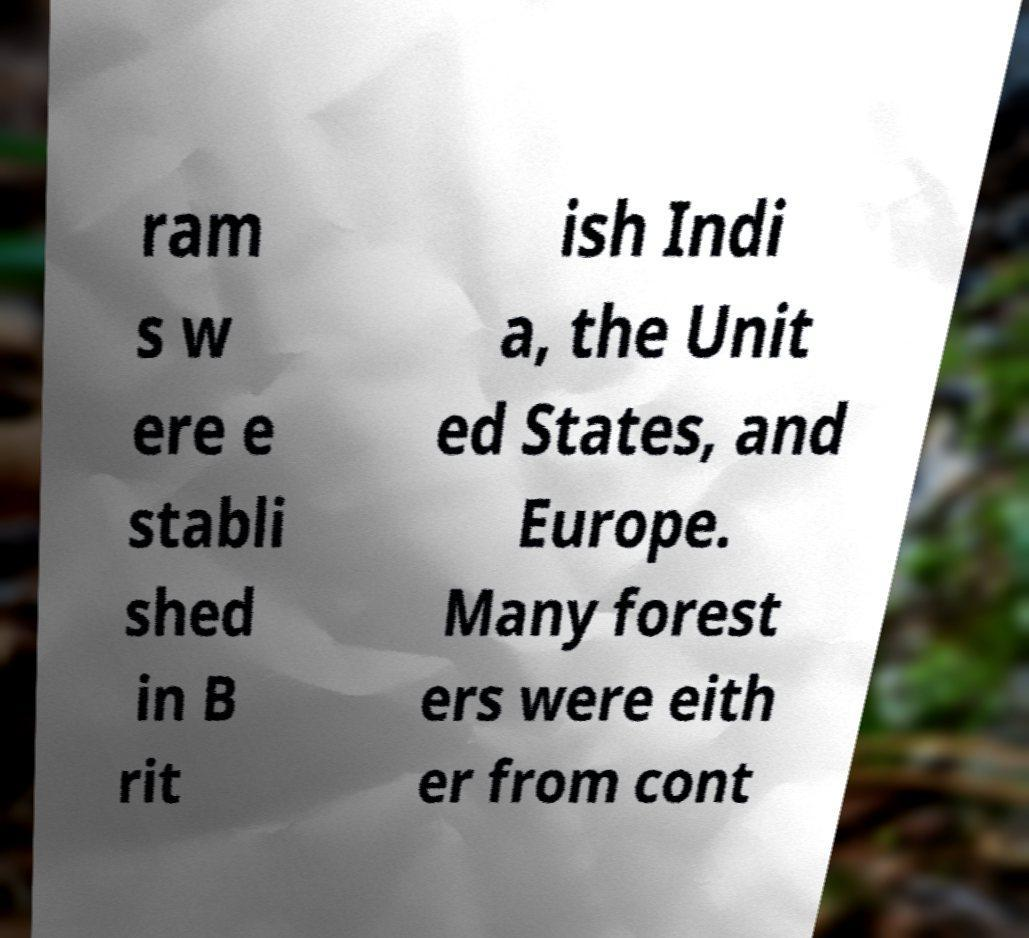Can you accurately transcribe the text from the provided image for me? ram s w ere e stabli shed in B rit ish Indi a, the Unit ed States, and Europe. Many forest ers were eith er from cont 